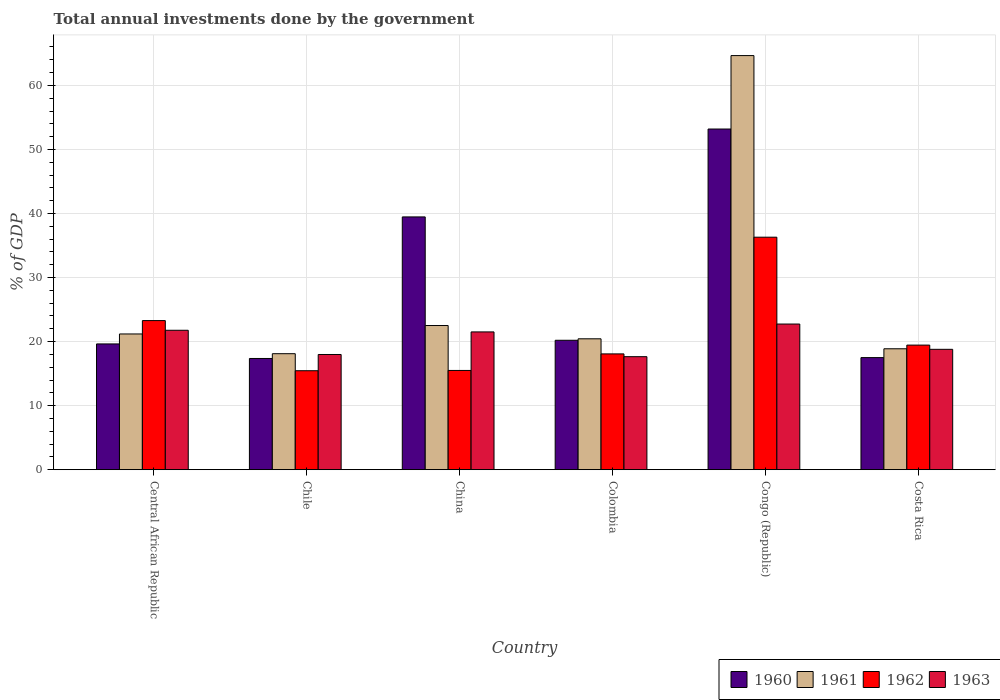How many different coloured bars are there?
Give a very brief answer. 4. How many groups of bars are there?
Ensure brevity in your answer.  6. Are the number of bars per tick equal to the number of legend labels?
Provide a short and direct response. Yes. How many bars are there on the 6th tick from the left?
Provide a succinct answer. 4. What is the label of the 6th group of bars from the left?
Provide a short and direct response. Costa Rica. In how many cases, is the number of bars for a given country not equal to the number of legend labels?
Your answer should be compact. 0. What is the total annual investments done by the government in 1960 in Central African Republic?
Ensure brevity in your answer.  19.64. Across all countries, what is the maximum total annual investments done by the government in 1962?
Make the answer very short. 36.3. Across all countries, what is the minimum total annual investments done by the government in 1963?
Provide a short and direct response. 17.64. In which country was the total annual investments done by the government in 1962 maximum?
Ensure brevity in your answer.  Congo (Republic). What is the total total annual investments done by the government in 1963 in the graph?
Your answer should be compact. 120.44. What is the difference between the total annual investments done by the government in 1960 in Central African Republic and that in Congo (Republic)?
Your answer should be compact. -33.55. What is the difference between the total annual investments done by the government in 1962 in Congo (Republic) and the total annual investments done by the government in 1960 in Colombia?
Your answer should be very brief. 16.09. What is the average total annual investments done by the government in 1960 per country?
Your answer should be compact. 27.89. What is the difference between the total annual investments done by the government of/in 1963 and total annual investments done by the government of/in 1962 in Colombia?
Ensure brevity in your answer.  -0.43. In how many countries, is the total annual investments done by the government in 1960 greater than 30 %?
Your answer should be compact. 2. What is the ratio of the total annual investments done by the government in 1963 in Chile to that in Congo (Republic)?
Give a very brief answer. 0.79. Is the difference between the total annual investments done by the government in 1963 in Central African Republic and Congo (Republic) greater than the difference between the total annual investments done by the government in 1962 in Central African Republic and Congo (Republic)?
Provide a short and direct response. Yes. What is the difference between the highest and the second highest total annual investments done by the government in 1960?
Your answer should be compact. -32.98. What is the difference between the highest and the lowest total annual investments done by the government in 1961?
Your answer should be compact. 46.54. Are all the bars in the graph horizontal?
Your response must be concise. No. How many countries are there in the graph?
Your response must be concise. 6. Does the graph contain any zero values?
Ensure brevity in your answer.  No. Where does the legend appear in the graph?
Offer a very short reply. Bottom right. How many legend labels are there?
Your answer should be very brief. 4. How are the legend labels stacked?
Your answer should be compact. Horizontal. What is the title of the graph?
Provide a succinct answer. Total annual investments done by the government. Does "1978" appear as one of the legend labels in the graph?
Offer a terse response. No. What is the label or title of the X-axis?
Your answer should be compact. Country. What is the label or title of the Y-axis?
Your response must be concise. % of GDP. What is the % of GDP of 1960 in Central African Republic?
Ensure brevity in your answer.  19.64. What is the % of GDP in 1961 in Central African Republic?
Provide a succinct answer. 21.19. What is the % of GDP of 1962 in Central African Republic?
Offer a very short reply. 23.28. What is the % of GDP in 1963 in Central African Republic?
Provide a succinct answer. 21.77. What is the % of GDP of 1960 in Chile?
Offer a very short reply. 17.36. What is the % of GDP of 1961 in Chile?
Offer a very short reply. 18.11. What is the % of GDP in 1962 in Chile?
Make the answer very short. 15.45. What is the % of GDP of 1963 in Chile?
Offer a very short reply. 17.99. What is the % of GDP in 1960 in China?
Give a very brief answer. 39.46. What is the % of GDP of 1961 in China?
Keep it short and to the point. 22.51. What is the % of GDP of 1962 in China?
Provide a short and direct response. 15.5. What is the % of GDP in 1963 in China?
Offer a very short reply. 21.51. What is the % of GDP in 1960 in Colombia?
Ensure brevity in your answer.  20.21. What is the % of GDP in 1961 in Colombia?
Your answer should be compact. 20.44. What is the % of GDP of 1962 in Colombia?
Your answer should be compact. 18.08. What is the % of GDP in 1963 in Colombia?
Offer a terse response. 17.64. What is the % of GDP in 1960 in Congo (Republic)?
Keep it short and to the point. 53.19. What is the % of GDP in 1961 in Congo (Republic)?
Your answer should be compact. 64.65. What is the % of GDP of 1962 in Congo (Republic)?
Provide a succinct answer. 36.3. What is the % of GDP in 1963 in Congo (Republic)?
Your answer should be very brief. 22.74. What is the % of GDP of 1960 in Costa Rica?
Keep it short and to the point. 17.5. What is the % of GDP of 1961 in Costa Rica?
Give a very brief answer. 18.88. What is the % of GDP in 1962 in Costa Rica?
Ensure brevity in your answer.  19.45. What is the % of GDP in 1963 in Costa Rica?
Provide a succinct answer. 18.79. Across all countries, what is the maximum % of GDP in 1960?
Offer a very short reply. 53.19. Across all countries, what is the maximum % of GDP of 1961?
Keep it short and to the point. 64.65. Across all countries, what is the maximum % of GDP in 1962?
Your response must be concise. 36.3. Across all countries, what is the maximum % of GDP of 1963?
Give a very brief answer. 22.74. Across all countries, what is the minimum % of GDP in 1960?
Your answer should be very brief. 17.36. Across all countries, what is the minimum % of GDP in 1961?
Offer a terse response. 18.11. Across all countries, what is the minimum % of GDP of 1962?
Give a very brief answer. 15.45. Across all countries, what is the minimum % of GDP of 1963?
Your response must be concise. 17.64. What is the total % of GDP in 1960 in the graph?
Keep it short and to the point. 167.36. What is the total % of GDP of 1961 in the graph?
Ensure brevity in your answer.  165.78. What is the total % of GDP of 1962 in the graph?
Give a very brief answer. 128.06. What is the total % of GDP in 1963 in the graph?
Your response must be concise. 120.44. What is the difference between the % of GDP in 1960 in Central African Republic and that in Chile?
Your answer should be very brief. 2.27. What is the difference between the % of GDP in 1961 in Central African Republic and that in Chile?
Your response must be concise. 3.08. What is the difference between the % of GDP of 1962 in Central African Republic and that in Chile?
Your answer should be compact. 7.83. What is the difference between the % of GDP of 1963 in Central African Republic and that in Chile?
Your response must be concise. 3.78. What is the difference between the % of GDP in 1960 in Central African Republic and that in China?
Keep it short and to the point. -19.83. What is the difference between the % of GDP in 1961 in Central African Republic and that in China?
Offer a very short reply. -1.32. What is the difference between the % of GDP in 1962 in Central African Republic and that in China?
Give a very brief answer. 7.78. What is the difference between the % of GDP in 1963 in Central African Republic and that in China?
Offer a very short reply. 0.26. What is the difference between the % of GDP in 1960 in Central African Republic and that in Colombia?
Provide a succinct answer. -0.57. What is the difference between the % of GDP in 1961 in Central African Republic and that in Colombia?
Keep it short and to the point. 0.76. What is the difference between the % of GDP in 1962 in Central African Republic and that in Colombia?
Make the answer very short. 5.2. What is the difference between the % of GDP of 1963 in Central African Republic and that in Colombia?
Provide a succinct answer. 4.12. What is the difference between the % of GDP in 1960 in Central African Republic and that in Congo (Republic)?
Provide a succinct answer. -33.55. What is the difference between the % of GDP of 1961 in Central African Republic and that in Congo (Republic)?
Offer a very short reply. -43.46. What is the difference between the % of GDP in 1962 in Central African Republic and that in Congo (Republic)?
Keep it short and to the point. -13.02. What is the difference between the % of GDP in 1963 in Central African Republic and that in Congo (Republic)?
Your response must be concise. -0.97. What is the difference between the % of GDP of 1960 in Central African Republic and that in Costa Rica?
Make the answer very short. 2.14. What is the difference between the % of GDP of 1961 in Central African Republic and that in Costa Rica?
Provide a succinct answer. 2.31. What is the difference between the % of GDP in 1962 in Central African Republic and that in Costa Rica?
Provide a succinct answer. 3.83. What is the difference between the % of GDP in 1963 in Central African Republic and that in Costa Rica?
Ensure brevity in your answer.  2.97. What is the difference between the % of GDP of 1960 in Chile and that in China?
Offer a very short reply. -22.1. What is the difference between the % of GDP of 1961 in Chile and that in China?
Provide a succinct answer. -4.4. What is the difference between the % of GDP of 1962 in Chile and that in China?
Provide a short and direct response. -0.05. What is the difference between the % of GDP in 1963 in Chile and that in China?
Your response must be concise. -3.52. What is the difference between the % of GDP of 1960 in Chile and that in Colombia?
Provide a succinct answer. -2.84. What is the difference between the % of GDP in 1961 in Chile and that in Colombia?
Provide a succinct answer. -2.33. What is the difference between the % of GDP in 1962 in Chile and that in Colombia?
Your answer should be compact. -2.63. What is the difference between the % of GDP of 1963 in Chile and that in Colombia?
Give a very brief answer. 0.34. What is the difference between the % of GDP of 1960 in Chile and that in Congo (Republic)?
Make the answer very short. -35.82. What is the difference between the % of GDP in 1961 in Chile and that in Congo (Republic)?
Make the answer very short. -46.54. What is the difference between the % of GDP in 1962 in Chile and that in Congo (Republic)?
Make the answer very short. -20.85. What is the difference between the % of GDP in 1963 in Chile and that in Congo (Republic)?
Your response must be concise. -4.75. What is the difference between the % of GDP in 1960 in Chile and that in Costa Rica?
Provide a succinct answer. -0.14. What is the difference between the % of GDP in 1961 in Chile and that in Costa Rica?
Your response must be concise. -0.77. What is the difference between the % of GDP of 1962 in Chile and that in Costa Rica?
Keep it short and to the point. -4. What is the difference between the % of GDP of 1963 in Chile and that in Costa Rica?
Make the answer very short. -0.81. What is the difference between the % of GDP of 1960 in China and that in Colombia?
Make the answer very short. 19.26. What is the difference between the % of GDP of 1961 in China and that in Colombia?
Your answer should be very brief. 2.07. What is the difference between the % of GDP of 1962 in China and that in Colombia?
Keep it short and to the point. -2.58. What is the difference between the % of GDP in 1963 in China and that in Colombia?
Your response must be concise. 3.87. What is the difference between the % of GDP of 1960 in China and that in Congo (Republic)?
Offer a very short reply. -13.72. What is the difference between the % of GDP in 1961 in China and that in Congo (Republic)?
Your answer should be very brief. -42.15. What is the difference between the % of GDP of 1962 in China and that in Congo (Republic)?
Your response must be concise. -20.8. What is the difference between the % of GDP in 1963 in China and that in Congo (Republic)?
Make the answer very short. -1.23. What is the difference between the % of GDP of 1960 in China and that in Costa Rica?
Provide a succinct answer. 21.96. What is the difference between the % of GDP of 1961 in China and that in Costa Rica?
Offer a terse response. 3.63. What is the difference between the % of GDP in 1962 in China and that in Costa Rica?
Provide a short and direct response. -3.96. What is the difference between the % of GDP of 1963 in China and that in Costa Rica?
Your response must be concise. 2.72. What is the difference between the % of GDP of 1960 in Colombia and that in Congo (Republic)?
Give a very brief answer. -32.98. What is the difference between the % of GDP in 1961 in Colombia and that in Congo (Republic)?
Offer a very short reply. -44.22. What is the difference between the % of GDP in 1962 in Colombia and that in Congo (Republic)?
Provide a short and direct response. -18.22. What is the difference between the % of GDP of 1963 in Colombia and that in Congo (Republic)?
Your response must be concise. -5.1. What is the difference between the % of GDP of 1960 in Colombia and that in Costa Rica?
Ensure brevity in your answer.  2.71. What is the difference between the % of GDP in 1961 in Colombia and that in Costa Rica?
Give a very brief answer. 1.56. What is the difference between the % of GDP in 1962 in Colombia and that in Costa Rica?
Ensure brevity in your answer.  -1.37. What is the difference between the % of GDP of 1963 in Colombia and that in Costa Rica?
Provide a succinct answer. -1.15. What is the difference between the % of GDP in 1960 in Congo (Republic) and that in Costa Rica?
Offer a terse response. 35.69. What is the difference between the % of GDP in 1961 in Congo (Republic) and that in Costa Rica?
Keep it short and to the point. 45.78. What is the difference between the % of GDP of 1962 in Congo (Republic) and that in Costa Rica?
Keep it short and to the point. 16.85. What is the difference between the % of GDP of 1963 in Congo (Republic) and that in Costa Rica?
Keep it short and to the point. 3.95. What is the difference between the % of GDP of 1960 in Central African Republic and the % of GDP of 1961 in Chile?
Offer a very short reply. 1.53. What is the difference between the % of GDP of 1960 in Central African Republic and the % of GDP of 1962 in Chile?
Your answer should be compact. 4.19. What is the difference between the % of GDP in 1960 in Central African Republic and the % of GDP in 1963 in Chile?
Provide a short and direct response. 1.65. What is the difference between the % of GDP in 1961 in Central African Republic and the % of GDP in 1962 in Chile?
Provide a succinct answer. 5.74. What is the difference between the % of GDP in 1961 in Central African Republic and the % of GDP in 1963 in Chile?
Ensure brevity in your answer.  3.21. What is the difference between the % of GDP in 1962 in Central African Republic and the % of GDP in 1963 in Chile?
Make the answer very short. 5.29. What is the difference between the % of GDP of 1960 in Central African Republic and the % of GDP of 1961 in China?
Make the answer very short. -2.87. What is the difference between the % of GDP in 1960 in Central African Republic and the % of GDP in 1962 in China?
Make the answer very short. 4.14. What is the difference between the % of GDP in 1960 in Central African Republic and the % of GDP in 1963 in China?
Make the answer very short. -1.88. What is the difference between the % of GDP in 1961 in Central African Republic and the % of GDP in 1962 in China?
Keep it short and to the point. 5.7. What is the difference between the % of GDP in 1961 in Central African Republic and the % of GDP in 1963 in China?
Provide a succinct answer. -0.32. What is the difference between the % of GDP of 1962 in Central African Republic and the % of GDP of 1963 in China?
Give a very brief answer. 1.77. What is the difference between the % of GDP of 1960 in Central African Republic and the % of GDP of 1961 in Colombia?
Your response must be concise. -0.8. What is the difference between the % of GDP of 1960 in Central African Republic and the % of GDP of 1962 in Colombia?
Offer a terse response. 1.56. What is the difference between the % of GDP of 1960 in Central African Republic and the % of GDP of 1963 in Colombia?
Offer a very short reply. 1.99. What is the difference between the % of GDP of 1961 in Central African Republic and the % of GDP of 1962 in Colombia?
Your response must be concise. 3.11. What is the difference between the % of GDP of 1961 in Central African Republic and the % of GDP of 1963 in Colombia?
Provide a short and direct response. 3.55. What is the difference between the % of GDP of 1962 in Central African Republic and the % of GDP of 1963 in Colombia?
Provide a succinct answer. 5.63. What is the difference between the % of GDP in 1960 in Central African Republic and the % of GDP in 1961 in Congo (Republic)?
Make the answer very short. -45.02. What is the difference between the % of GDP in 1960 in Central African Republic and the % of GDP in 1962 in Congo (Republic)?
Your answer should be compact. -16.66. What is the difference between the % of GDP in 1960 in Central African Republic and the % of GDP in 1963 in Congo (Republic)?
Ensure brevity in your answer.  -3.1. What is the difference between the % of GDP of 1961 in Central African Republic and the % of GDP of 1962 in Congo (Republic)?
Give a very brief answer. -15.11. What is the difference between the % of GDP of 1961 in Central African Republic and the % of GDP of 1963 in Congo (Republic)?
Ensure brevity in your answer.  -1.55. What is the difference between the % of GDP in 1962 in Central African Republic and the % of GDP in 1963 in Congo (Republic)?
Keep it short and to the point. 0.54. What is the difference between the % of GDP of 1960 in Central African Republic and the % of GDP of 1961 in Costa Rica?
Offer a very short reply. 0.76. What is the difference between the % of GDP of 1960 in Central African Republic and the % of GDP of 1962 in Costa Rica?
Ensure brevity in your answer.  0.18. What is the difference between the % of GDP in 1960 in Central African Republic and the % of GDP in 1963 in Costa Rica?
Ensure brevity in your answer.  0.84. What is the difference between the % of GDP of 1961 in Central African Republic and the % of GDP of 1962 in Costa Rica?
Provide a succinct answer. 1.74. What is the difference between the % of GDP in 1961 in Central African Republic and the % of GDP in 1963 in Costa Rica?
Your response must be concise. 2.4. What is the difference between the % of GDP in 1962 in Central African Republic and the % of GDP in 1963 in Costa Rica?
Keep it short and to the point. 4.48. What is the difference between the % of GDP in 1960 in Chile and the % of GDP in 1961 in China?
Provide a short and direct response. -5.14. What is the difference between the % of GDP of 1960 in Chile and the % of GDP of 1962 in China?
Provide a succinct answer. 1.87. What is the difference between the % of GDP of 1960 in Chile and the % of GDP of 1963 in China?
Give a very brief answer. -4.15. What is the difference between the % of GDP of 1961 in Chile and the % of GDP of 1962 in China?
Give a very brief answer. 2.61. What is the difference between the % of GDP in 1961 in Chile and the % of GDP in 1963 in China?
Your response must be concise. -3.4. What is the difference between the % of GDP of 1962 in Chile and the % of GDP of 1963 in China?
Provide a short and direct response. -6.06. What is the difference between the % of GDP in 1960 in Chile and the % of GDP in 1961 in Colombia?
Your answer should be compact. -3.07. What is the difference between the % of GDP of 1960 in Chile and the % of GDP of 1962 in Colombia?
Offer a terse response. -0.72. What is the difference between the % of GDP in 1960 in Chile and the % of GDP in 1963 in Colombia?
Your answer should be very brief. -0.28. What is the difference between the % of GDP in 1961 in Chile and the % of GDP in 1962 in Colombia?
Provide a short and direct response. 0.03. What is the difference between the % of GDP in 1961 in Chile and the % of GDP in 1963 in Colombia?
Your answer should be very brief. 0.47. What is the difference between the % of GDP of 1962 in Chile and the % of GDP of 1963 in Colombia?
Make the answer very short. -2.19. What is the difference between the % of GDP of 1960 in Chile and the % of GDP of 1961 in Congo (Republic)?
Keep it short and to the point. -47.29. What is the difference between the % of GDP of 1960 in Chile and the % of GDP of 1962 in Congo (Republic)?
Provide a short and direct response. -18.93. What is the difference between the % of GDP of 1960 in Chile and the % of GDP of 1963 in Congo (Republic)?
Ensure brevity in your answer.  -5.38. What is the difference between the % of GDP of 1961 in Chile and the % of GDP of 1962 in Congo (Republic)?
Make the answer very short. -18.19. What is the difference between the % of GDP in 1961 in Chile and the % of GDP in 1963 in Congo (Republic)?
Offer a very short reply. -4.63. What is the difference between the % of GDP in 1962 in Chile and the % of GDP in 1963 in Congo (Republic)?
Your answer should be compact. -7.29. What is the difference between the % of GDP in 1960 in Chile and the % of GDP in 1961 in Costa Rica?
Your answer should be very brief. -1.51. What is the difference between the % of GDP of 1960 in Chile and the % of GDP of 1962 in Costa Rica?
Ensure brevity in your answer.  -2.09. What is the difference between the % of GDP of 1960 in Chile and the % of GDP of 1963 in Costa Rica?
Provide a short and direct response. -1.43. What is the difference between the % of GDP in 1961 in Chile and the % of GDP in 1962 in Costa Rica?
Provide a short and direct response. -1.34. What is the difference between the % of GDP in 1961 in Chile and the % of GDP in 1963 in Costa Rica?
Provide a succinct answer. -0.68. What is the difference between the % of GDP of 1962 in Chile and the % of GDP of 1963 in Costa Rica?
Ensure brevity in your answer.  -3.34. What is the difference between the % of GDP in 1960 in China and the % of GDP in 1961 in Colombia?
Offer a terse response. 19.03. What is the difference between the % of GDP in 1960 in China and the % of GDP in 1962 in Colombia?
Provide a succinct answer. 21.39. What is the difference between the % of GDP in 1960 in China and the % of GDP in 1963 in Colombia?
Provide a short and direct response. 21.82. What is the difference between the % of GDP of 1961 in China and the % of GDP of 1962 in Colombia?
Ensure brevity in your answer.  4.43. What is the difference between the % of GDP in 1961 in China and the % of GDP in 1963 in Colombia?
Offer a terse response. 4.86. What is the difference between the % of GDP in 1962 in China and the % of GDP in 1963 in Colombia?
Provide a short and direct response. -2.15. What is the difference between the % of GDP of 1960 in China and the % of GDP of 1961 in Congo (Republic)?
Offer a very short reply. -25.19. What is the difference between the % of GDP of 1960 in China and the % of GDP of 1962 in Congo (Republic)?
Make the answer very short. 3.17. What is the difference between the % of GDP in 1960 in China and the % of GDP in 1963 in Congo (Republic)?
Offer a very short reply. 16.72. What is the difference between the % of GDP of 1961 in China and the % of GDP of 1962 in Congo (Republic)?
Your answer should be compact. -13.79. What is the difference between the % of GDP of 1961 in China and the % of GDP of 1963 in Congo (Republic)?
Give a very brief answer. -0.23. What is the difference between the % of GDP in 1962 in China and the % of GDP in 1963 in Congo (Republic)?
Your answer should be very brief. -7.24. What is the difference between the % of GDP of 1960 in China and the % of GDP of 1961 in Costa Rica?
Keep it short and to the point. 20.59. What is the difference between the % of GDP in 1960 in China and the % of GDP in 1962 in Costa Rica?
Your response must be concise. 20.01. What is the difference between the % of GDP in 1960 in China and the % of GDP in 1963 in Costa Rica?
Give a very brief answer. 20.67. What is the difference between the % of GDP of 1961 in China and the % of GDP of 1962 in Costa Rica?
Your answer should be very brief. 3.05. What is the difference between the % of GDP of 1961 in China and the % of GDP of 1963 in Costa Rica?
Offer a terse response. 3.71. What is the difference between the % of GDP in 1962 in China and the % of GDP in 1963 in Costa Rica?
Provide a succinct answer. -3.3. What is the difference between the % of GDP in 1960 in Colombia and the % of GDP in 1961 in Congo (Republic)?
Keep it short and to the point. -44.45. What is the difference between the % of GDP in 1960 in Colombia and the % of GDP in 1962 in Congo (Republic)?
Provide a short and direct response. -16.09. What is the difference between the % of GDP of 1960 in Colombia and the % of GDP of 1963 in Congo (Republic)?
Your answer should be very brief. -2.54. What is the difference between the % of GDP of 1961 in Colombia and the % of GDP of 1962 in Congo (Republic)?
Your response must be concise. -15.86. What is the difference between the % of GDP of 1961 in Colombia and the % of GDP of 1963 in Congo (Republic)?
Offer a terse response. -2.3. What is the difference between the % of GDP in 1962 in Colombia and the % of GDP in 1963 in Congo (Republic)?
Your response must be concise. -4.66. What is the difference between the % of GDP in 1960 in Colombia and the % of GDP in 1961 in Costa Rica?
Offer a terse response. 1.33. What is the difference between the % of GDP of 1960 in Colombia and the % of GDP of 1962 in Costa Rica?
Your response must be concise. 0.75. What is the difference between the % of GDP in 1960 in Colombia and the % of GDP in 1963 in Costa Rica?
Make the answer very short. 1.41. What is the difference between the % of GDP of 1961 in Colombia and the % of GDP of 1962 in Costa Rica?
Offer a terse response. 0.98. What is the difference between the % of GDP of 1961 in Colombia and the % of GDP of 1963 in Costa Rica?
Keep it short and to the point. 1.64. What is the difference between the % of GDP of 1962 in Colombia and the % of GDP of 1963 in Costa Rica?
Your answer should be compact. -0.72. What is the difference between the % of GDP in 1960 in Congo (Republic) and the % of GDP in 1961 in Costa Rica?
Your response must be concise. 34.31. What is the difference between the % of GDP of 1960 in Congo (Republic) and the % of GDP of 1962 in Costa Rica?
Your response must be concise. 33.73. What is the difference between the % of GDP of 1960 in Congo (Republic) and the % of GDP of 1963 in Costa Rica?
Make the answer very short. 34.39. What is the difference between the % of GDP of 1961 in Congo (Republic) and the % of GDP of 1962 in Costa Rica?
Keep it short and to the point. 45.2. What is the difference between the % of GDP in 1961 in Congo (Republic) and the % of GDP in 1963 in Costa Rica?
Keep it short and to the point. 45.86. What is the difference between the % of GDP in 1962 in Congo (Republic) and the % of GDP in 1963 in Costa Rica?
Provide a succinct answer. 17.5. What is the average % of GDP in 1960 per country?
Your answer should be very brief. 27.89. What is the average % of GDP in 1961 per country?
Ensure brevity in your answer.  27.63. What is the average % of GDP in 1962 per country?
Keep it short and to the point. 21.34. What is the average % of GDP of 1963 per country?
Your answer should be very brief. 20.07. What is the difference between the % of GDP in 1960 and % of GDP in 1961 in Central African Republic?
Provide a short and direct response. -1.56. What is the difference between the % of GDP of 1960 and % of GDP of 1962 in Central African Republic?
Ensure brevity in your answer.  -3.64. What is the difference between the % of GDP of 1960 and % of GDP of 1963 in Central African Republic?
Give a very brief answer. -2.13. What is the difference between the % of GDP of 1961 and % of GDP of 1962 in Central African Republic?
Offer a very short reply. -2.09. What is the difference between the % of GDP in 1961 and % of GDP in 1963 in Central African Republic?
Your response must be concise. -0.57. What is the difference between the % of GDP in 1962 and % of GDP in 1963 in Central African Republic?
Ensure brevity in your answer.  1.51. What is the difference between the % of GDP of 1960 and % of GDP of 1961 in Chile?
Give a very brief answer. -0.75. What is the difference between the % of GDP in 1960 and % of GDP in 1962 in Chile?
Ensure brevity in your answer.  1.91. What is the difference between the % of GDP in 1960 and % of GDP in 1963 in Chile?
Offer a very short reply. -0.62. What is the difference between the % of GDP in 1961 and % of GDP in 1962 in Chile?
Your answer should be very brief. 2.66. What is the difference between the % of GDP of 1961 and % of GDP of 1963 in Chile?
Give a very brief answer. 0.12. What is the difference between the % of GDP in 1962 and % of GDP in 1963 in Chile?
Offer a very short reply. -2.54. What is the difference between the % of GDP of 1960 and % of GDP of 1961 in China?
Make the answer very short. 16.96. What is the difference between the % of GDP in 1960 and % of GDP in 1962 in China?
Offer a very short reply. 23.97. What is the difference between the % of GDP in 1960 and % of GDP in 1963 in China?
Your answer should be compact. 17.95. What is the difference between the % of GDP of 1961 and % of GDP of 1962 in China?
Provide a short and direct response. 7.01. What is the difference between the % of GDP in 1961 and % of GDP in 1963 in China?
Offer a terse response. 1. What is the difference between the % of GDP in 1962 and % of GDP in 1963 in China?
Provide a succinct answer. -6.01. What is the difference between the % of GDP in 1960 and % of GDP in 1961 in Colombia?
Your response must be concise. -0.23. What is the difference between the % of GDP in 1960 and % of GDP in 1962 in Colombia?
Your response must be concise. 2.13. What is the difference between the % of GDP in 1960 and % of GDP in 1963 in Colombia?
Your response must be concise. 2.56. What is the difference between the % of GDP in 1961 and % of GDP in 1962 in Colombia?
Your response must be concise. 2.36. What is the difference between the % of GDP in 1961 and % of GDP in 1963 in Colombia?
Your response must be concise. 2.79. What is the difference between the % of GDP in 1962 and % of GDP in 1963 in Colombia?
Offer a very short reply. 0.43. What is the difference between the % of GDP of 1960 and % of GDP of 1961 in Congo (Republic)?
Ensure brevity in your answer.  -11.47. What is the difference between the % of GDP in 1960 and % of GDP in 1962 in Congo (Republic)?
Your response must be concise. 16.89. What is the difference between the % of GDP of 1960 and % of GDP of 1963 in Congo (Republic)?
Ensure brevity in your answer.  30.45. What is the difference between the % of GDP in 1961 and % of GDP in 1962 in Congo (Republic)?
Keep it short and to the point. 28.36. What is the difference between the % of GDP in 1961 and % of GDP in 1963 in Congo (Republic)?
Offer a very short reply. 41.91. What is the difference between the % of GDP of 1962 and % of GDP of 1963 in Congo (Republic)?
Offer a terse response. 13.56. What is the difference between the % of GDP of 1960 and % of GDP of 1961 in Costa Rica?
Provide a succinct answer. -1.38. What is the difference between the % of GDP of 1960 and % of GDP of 1962 in Costa Rica?
Make the answer very short. -1.95. What is the difference between the % of GDP in 1960 and % of GDP in 1963 in Costa Rica?
Offer a terse response. -1.29. What is the difference between the % of GDP in 1961 and % of GDP in 1962 in Costa Rica?
Your response must be concise. -0.58. What is the difference between the % of GDP of 1961 and % of GDP of 1963 in Costa Rica?
Provide a short and direct response. 0.08. What is the difference between the % of GDP in 1962 and % of GDP in 1963 in Costa Rica?
Your answer should be compact. 0.66. What is the ratio of the % of GDP in 1960 in Central African Republic to that in Chile?
Your response must be concise. 1.13. What is the ratio of the % of GDP in 1961 in Central African Republic to that in Chile?
Provide a short and direct response. 1.17. What is the ratio of the % of GDP in 1962 in Central African Republic to that in Chile?
Provide a short and direct response. 1.51. What is the ratio of the % of GDP in 1963 in Central African Republic to that in Chile?
Your answer should be compact. 1.21. What is the ratio of the % of GDP of 1960 in Central African Republic to that in China?
Keep it short and to the point. 0.5. What is the ratio of the % of GDP in 1961 in Central African Republic to that in China?
Your response must be concise. 0.94. What is the ratio of the % of GDP in 1962 in Central African Republic to that in China?
Make the answer very short. 1.5. What is the ratio of the % of GDP of 1963 in Central African Republic to that in China?
Give a very brief answer. 1.01. What is the ratio of the % of GDP in 1960 in Central African Republic to that in Colombia?
Offer a terse response. 0.97. What is the ratio of the % of GDP in 1961 in Central African Republic to that in Colombia?
Offer a terse response. 1.04. What is the ratio of the % of GDP of 1962 in Central African Republic to that in Colombia?
Ensure brevity in your answer.  1.29. What is the ratio of the % of GDP in 1963 in Central African Republic to that in Colombia?
Provide a short and direct response. 1.23. What is the ratio of the % of GDP in 1960 in Central African Republic to that in Congo (Republic)?
Your answer should be very brief. 0.37. What is the ratio of the % of GDP in 1961 in Central African Republic to that in Congo (Republic)?
Provide a short and direct response. 0.33. What is the ratio of the % of GDP of 1962 in Central African Republic to that in Congo (Republic)?
Give a very brief answer. 0.64. What is the ratio of the % of GDP in 1963 in Central African Republic to that in Congo (Republic)?
Provide a short and direct response. 0.96. What is the ratio of the % of GDP in 1960 in Central African Republic to that in Costa Rica?
Make the answer very short. 1.12. What is the ratio of the % of GDP of 1961 in Central African Republic to that in Costa Rica?
Your response must be concise. 1.12. What is the ratio of the % of GDP of 1962 in Central African Republic to that in Costa Rica?
Provide a succinct answer. 1.2. What is the ratio of the % of GDP of 1963 in Central African Republic to that in Costa Rica?
Make the answer very short. 1.16. What is the ratio of the % of GDP of 1960 in Chile to that in China?
Your answer should be compact. 0.44. What is the ratio of the % of GDP of 1961 in Chile to that in China?
Your answer should be compact. 0.8. What is the ratio of the % of GDP of 1962 in Chile to that in China?
Your response must be concise. 1. What is the ratio of the % of GDP in 1963 in Chile to that in China?
Your answer should be compact. 0.84. What is the ratio of the % of GDP in 1960 in Chile to that in Colombia?
Make the answer very short. 0.86. What is the ratio of the % of GDP in 1961 in Chile to that in Colombia?
Provide a short and direct response. 0.89. What is the ratio of the % of GDP in 1962 in Chile to that in Colombia?
Give a very brief answer. 0.85. What is the ratio of the % of GDP in 1963 in Chile to that in Colombia?
Provide a short and direct response. 1.02. What is the ratio of the % of GDP of 1960 in Chile to that in Congo (Republic)?
Ensure brevity in your answer.  0.33. What is the ratio of the % of GDP of 1961 in Chile to that in Congo (Republic)?
Offer a terse response. 0.28. What is the ratio of the % of GDP of 1962 in Chile to that in Congo (Republic)?
Make the answer very short. 0.43. What is the ratio of the % of GDP of 1963 in Chile to that in Congo (Republic)?
Keep it short and to the point. 0.79. What is the ratio of the % of GDP in 1961 in Chile to that in Costa Rica?
Keep it short and to the point. 0.96. What is the ratio of the % of GDP in 1962 in Chile to that in Costa Rica?
Ensure brevity in your answer.  0.79. What is the ratio of the % of GDP in 1960 in China to that in Colombia?
Make the answer very short. 1.95. What is the ratio of the % of GDP of 1961 in China to that in Colombia?
Your answer should be compact. 1.1. What is the ratio of the % of GDP in 1962 in China to that in Colombia?
Make the answer very short. 0.86. What is the ratio of the % of GDP in 1963 in China to that in Colombia?
Ensure brevity in your answer.  1.22. What is the ratio of the % of GDP in 1960 in China to that in Congo (Republic)?
Offer a terse response. 0.74. What is the ratio of the % of GDP in 1961 in China to that in Congo (Republic)?
Give a very brief answer. 0.35. What is the ratio of the % of GDP in 1962 in China to that in Congo (Republic)?
Your response must be concise. 0.43. What is the ratio of the % of GDP of 1963 in China to that in Congo (Republic)?
Keep it short and to the point. 0.95. What is the ratio of the % of GDP of 1960 in China to that in Costa Rica?
Offer a terse response. 2.26. What is the ratio of the % of GDP of 1961 in China to that in Costa Rica?
Give a very brief answer. 1.19. What is the ratio of the % of GDP in 1962 in China to that in Costa Rica?
Your answer should be compact. 0.8. What is the ratio of the % of GDP of 1963 in China to that in Costa Rica?
Give a very brief answer. 1.14. What is the ratio of the % of GDP of 1960 in Colombia to that in Congo (Republic)?
Your response must be concise. 0.38. What is the ratio of the % of GDP in 1961 in Colombia to that in Congo (Republic)?
Make the answer very short. 0.32. What is the ratio of the % of GDP in 1962 in Colombia to that in Congo (Republic)?
Ensure brevity in your answer.  0.5. What is the ratio of the % of GDP of 1963 in Colombia to that in Congo (Republic)?
Keep it short and to the point. 0.78. What is the ratio of the % of GDP in 1960 in Colombia to that in Costa Rica?
Keep it short and to the point. 1.15. What is the ratio of the % of GDP in 1961 in Colombia to that in Costa Rica?
Make the answer very short. 1.08. What is the ratio of the % of GDP of 1962 in Colombia to that in Costa Rica?
Keep it short and to the point. 0.93. What is the ratio of the % of GDP in 1963 in Colombia to that in Costa Rica?
Make the answer very short. 0.94. What is the ratio of the % of GDP in 1960 in Congo (Republic) to that in Costa Rica?
Your answer should be very brief. 3.04. What is the ratio of the % of GDP of 1961 in Congo (Republic) to that in Costa Rica?
Your response must be concise. 3.42. What is the ratio of the % of GDP of 1962 in Congo (Republic) to that in Costa Rica?
Ensure brevity in your answer.  1.87. What is the ratio of the % of GDP in 1963 in Congo (Republic) to that in Costa Rica?
Provide a short and direct response. 1.21. What is the difference between the highest and the second highest % of GDP in 1960?
Keep it short and to the point. 13.72. What is the difference between the highest and the second highest % of GDP of 1961?
Offer a very short reply. 42.15. What is the difference between the highest and the second highest % of GDP of 1962?
Keep it short and to the point. 13.02. What is the difference between the highest and the second highest % of GDP in 1963?
Keep it short and to the point. 0.97. What is the difference between the highest and the lowest % of GDP in 1960?
Make the answer very short. 35.82. What is the difference between the highest and the lowest % of GDP of 1961?
Make the answer very short. 46.54. What is the difference between the highest and the lowest % of GDP in 1962?
Your answer should be compact. 20.85. What is the difference between the highest and the lowest % of GDP in 1963?
Offer a terse response. 5.1. 